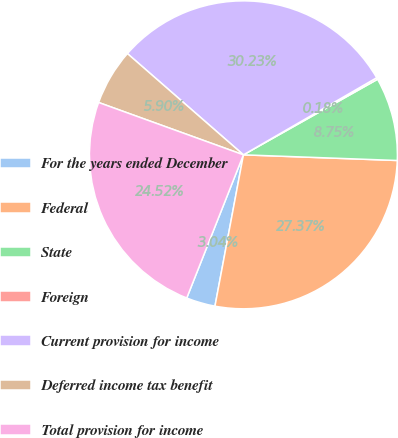Convert chart to OTSL. <chart><loc_0><loc_0><loc_500><loc_500><pie_chart><fcel>For the years ended December<fcel>Federal<fcel>State<fcel>Foreign<fcel>Current provision for income<fcel>Deferred income tax benefit<fcel>Total provision for income<nl><fcel>3.04%<fcel>27.37%<fcel>8.75%<fcel>0.18%<fcel>30.23%<fcel>5.9%<fcel>24.52%<nl></chart> 